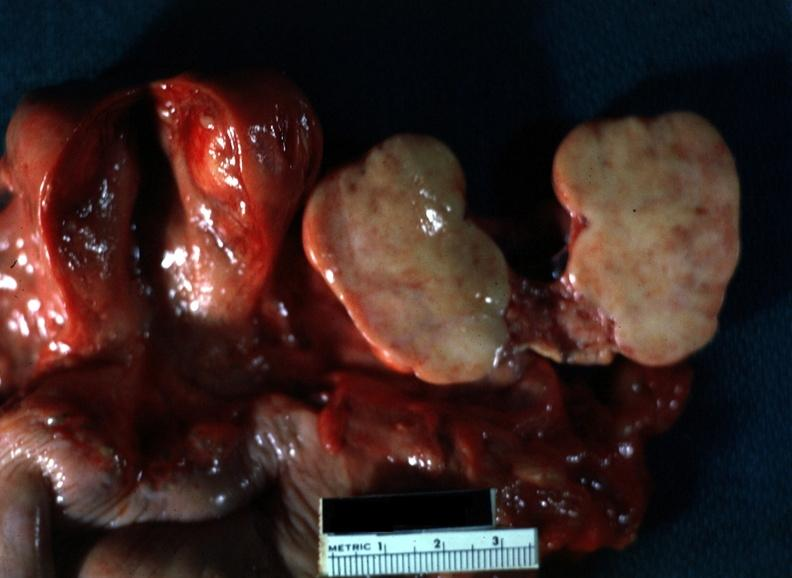s female reproductive present?
Answer the question using a single word or phrase. Yes 